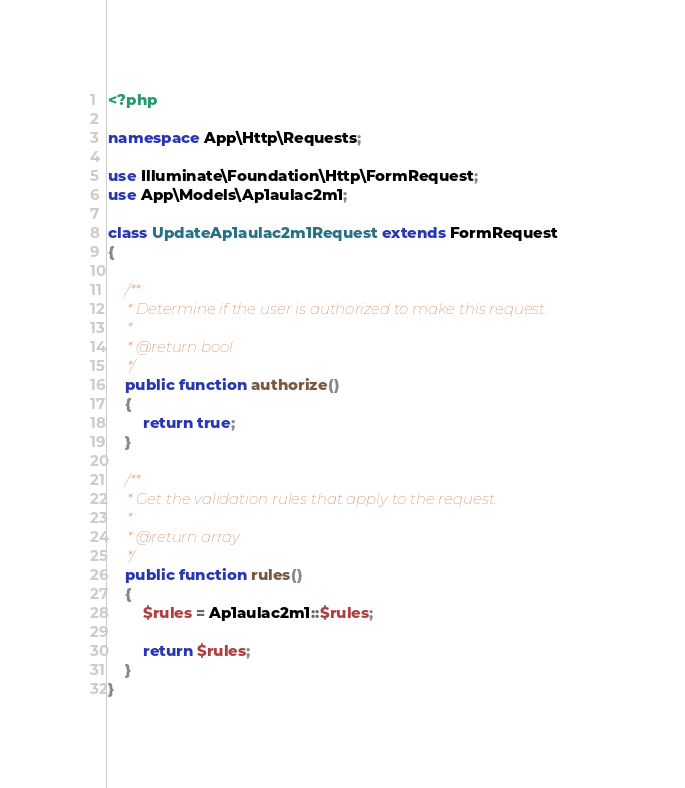<code> <loc_0><loc_0><loc_500><loc_500><_PHP_><?php

namespace App\Http\Requests;

use Illuminate\Foundation\Http\FormRequest;
use App\Models\Ap1aulac2m1;

class UpdateAp1aulac2m1Request extends FormRequest
{

    /**
     * Determine if the user is authorized to make this request.
     *
     * @return bool
     */
    public function authorize()
    {
        return true;
    }

    /**
     * Get the validation rules that apply to the request.
     *
     * @return array
     */
    public function rules()
    {
        $rules = Ap1aulac2m1::$rules;
        
        return $rules;
    }
}
</code> 